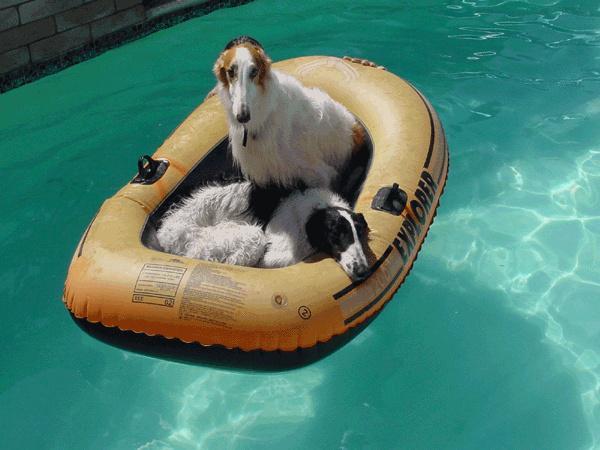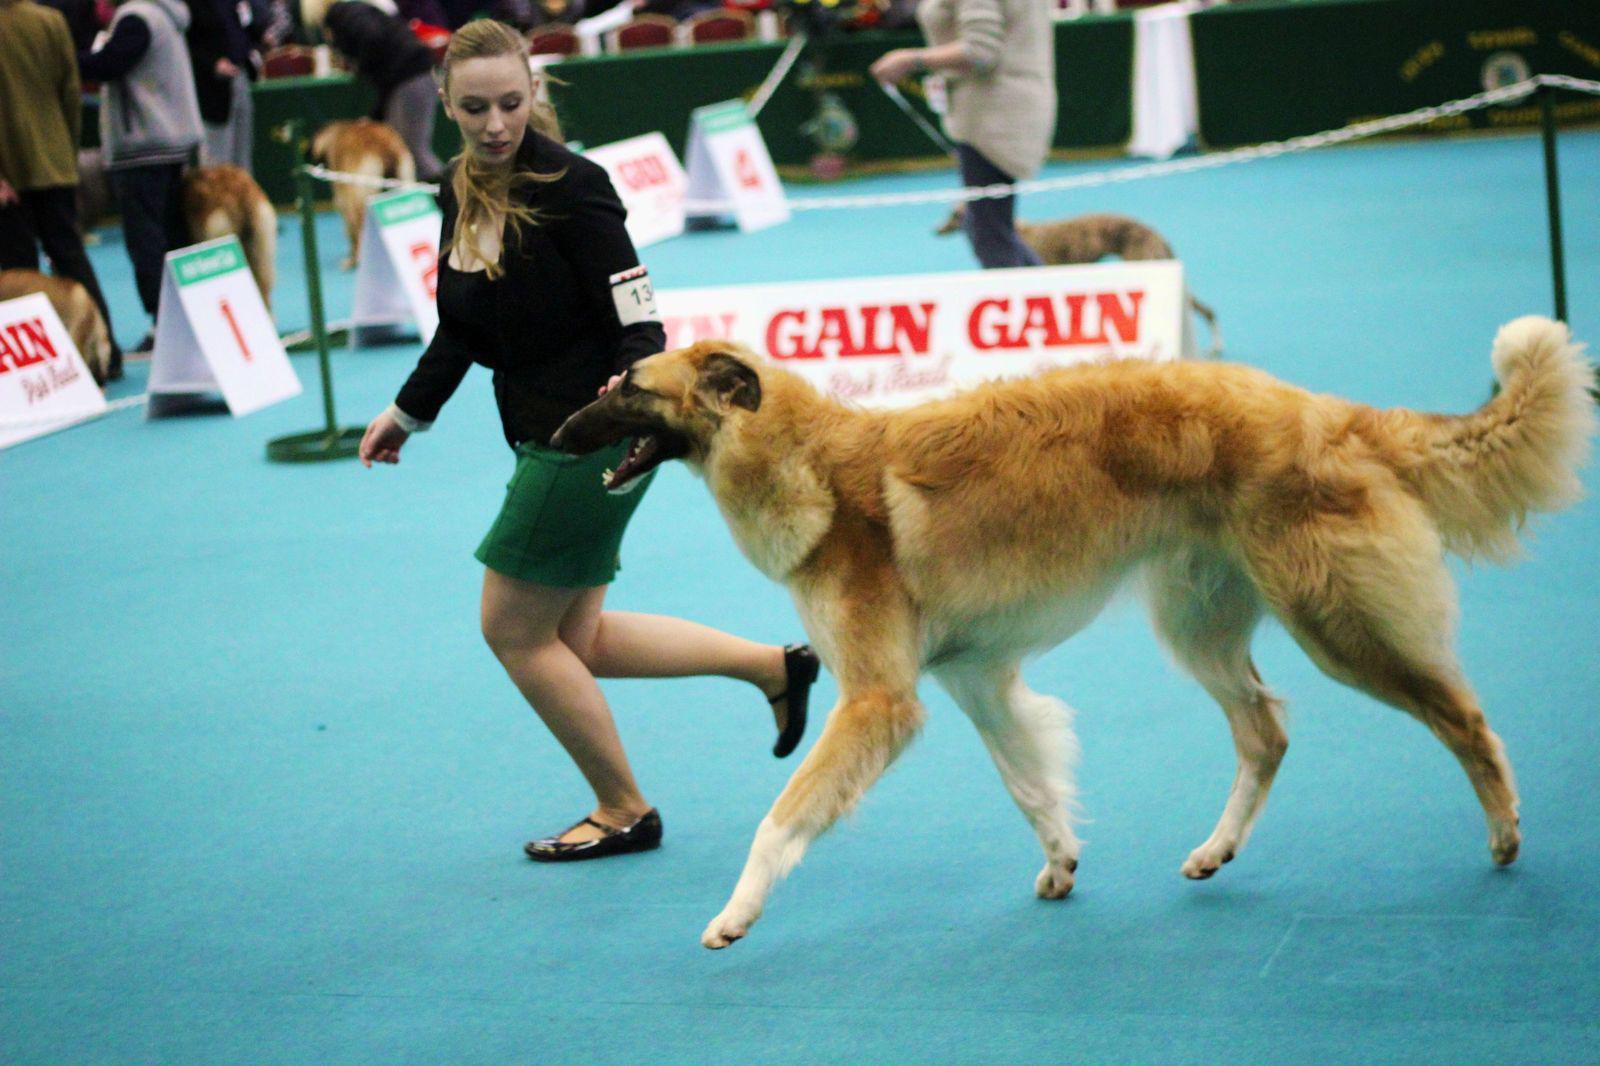The first image is the image on the left, the second image is the image on the right. For the images shown, is this caption "One image shows at least one hound in a raft on water, and the other image shows a hound that is upright and trotting." true? Answer yes or no. Yes. The first image is the image on the left, the second image is the image on the right. Considering the images on both sides, is "An image contains at least one dog inside an inflatable flotation device." valid? Answer yes or no. Yes. 